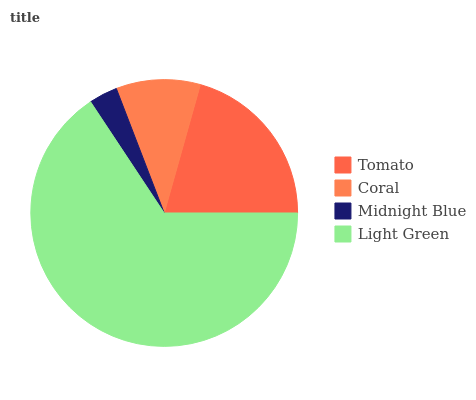Is Midnight Blue the minimum?
Answer yes or no. Yes. Is Light Green the maximum?
Answer yes or no. Yes. Is Coral the minimum?
Answer yes or no. No. Is Coral the maximum?
Answer yes or no. No. Is Tomato greater than Coral?
Answer yes or no. Yes. Is Coral less than Tomato?
Answer yes or no. Yes. Is Coral greater than Tomato?
Answer yes or no. No. Is Tomato less than Coral?
Answer yes or no. No. Is Tomato the high median?
Answer yes or no. Yes. Is Coral the low median?
Answer yes or no. Yes. Is Midnight Blue the high median?
Answer yes or no. No. Is Midnight Blue the low median?
Answer yes or no. No. 